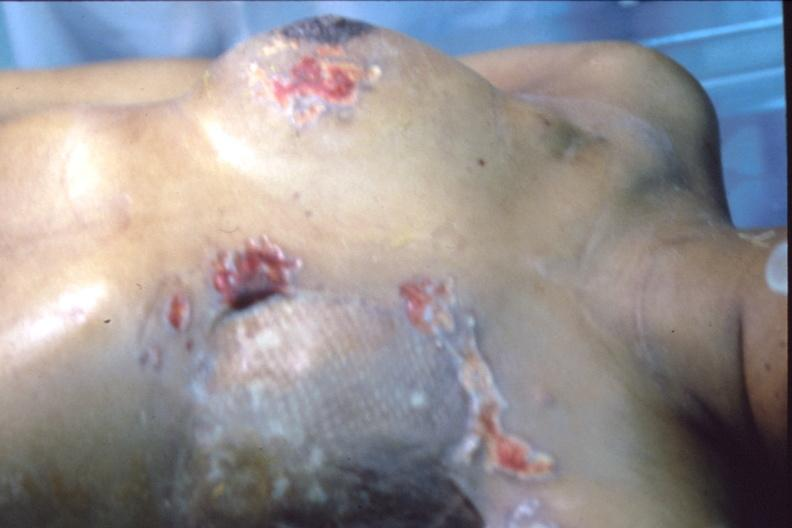does carcinomatosis show mastectomy scars with skin metastases?
Answer the question using a single word or phrase. No 